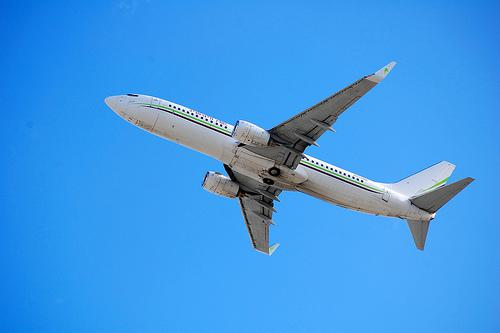Can you guess at what altitude the plane might be flying? Without specific data, it's hard to determine the exact altitude, but commercial airplanes typically cruise at altitudes around 35,000 feet (approximately 10,668 meters). 